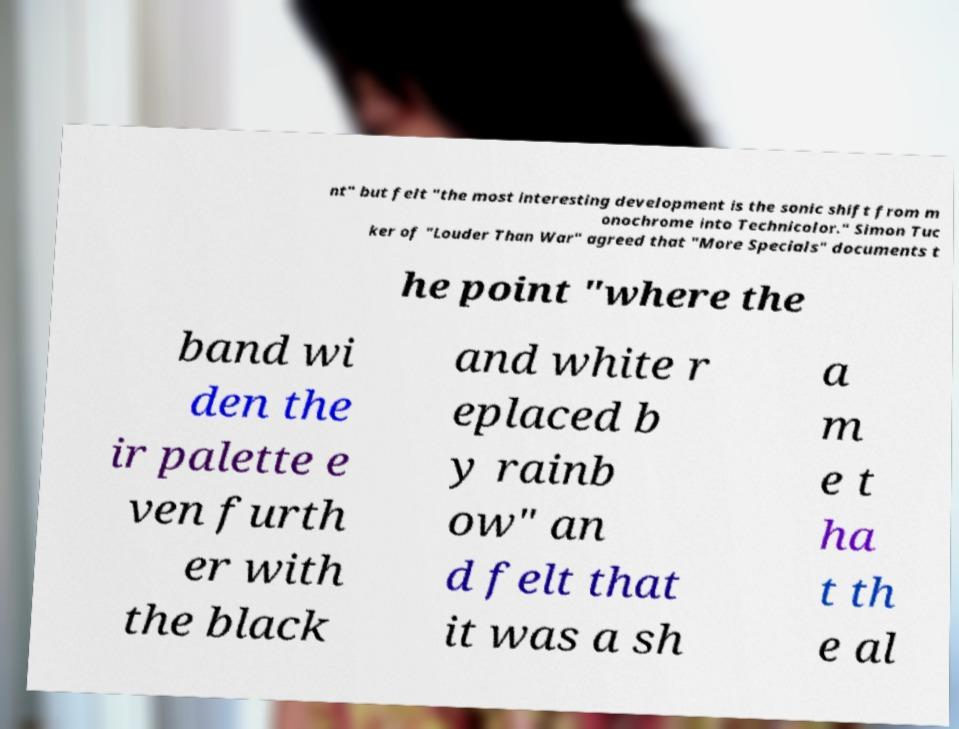What messages or text are displayed in this image? I need them in a readable, typed format. nt" but felt "the most interesting development is the sonic shift from m onochrome into Technicolor." Simon Tuc ker of "Louder Than War" agreed that "More Specials" documents t he point "where the band wi den the ir palette e ven furth er with the black and white r eplaced b y rainb ow" an d felt that it was a sh a m e t ha t th e al 